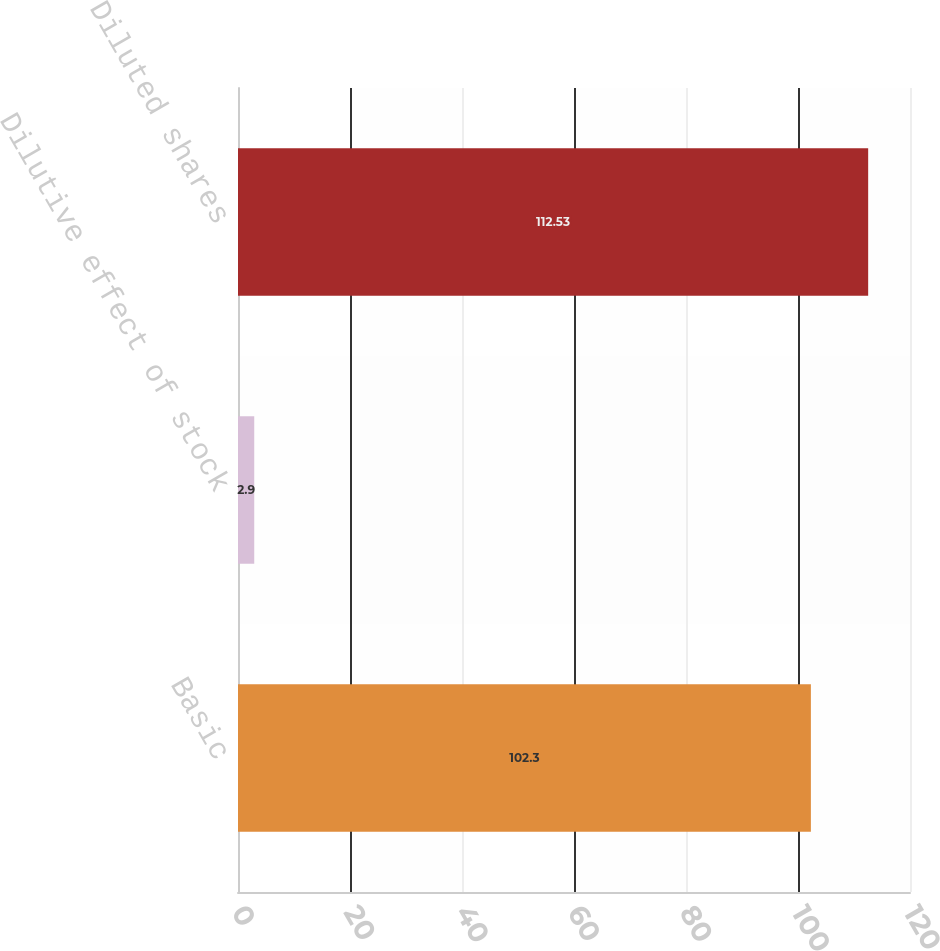<chart> <loc_0><loc_0><loc_500><loc_500><bar_chart><fcel>Basic<fcel>Dilutive effect of stock<fcel>Diluted shares<nl><fcel>102.3<fcel>2.9<fcel>112.53<nl></chart> 